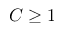Convert formula to latex. <formula><loc_0><loc_0><loc_500><loc_500>C \geq 1</formula> 